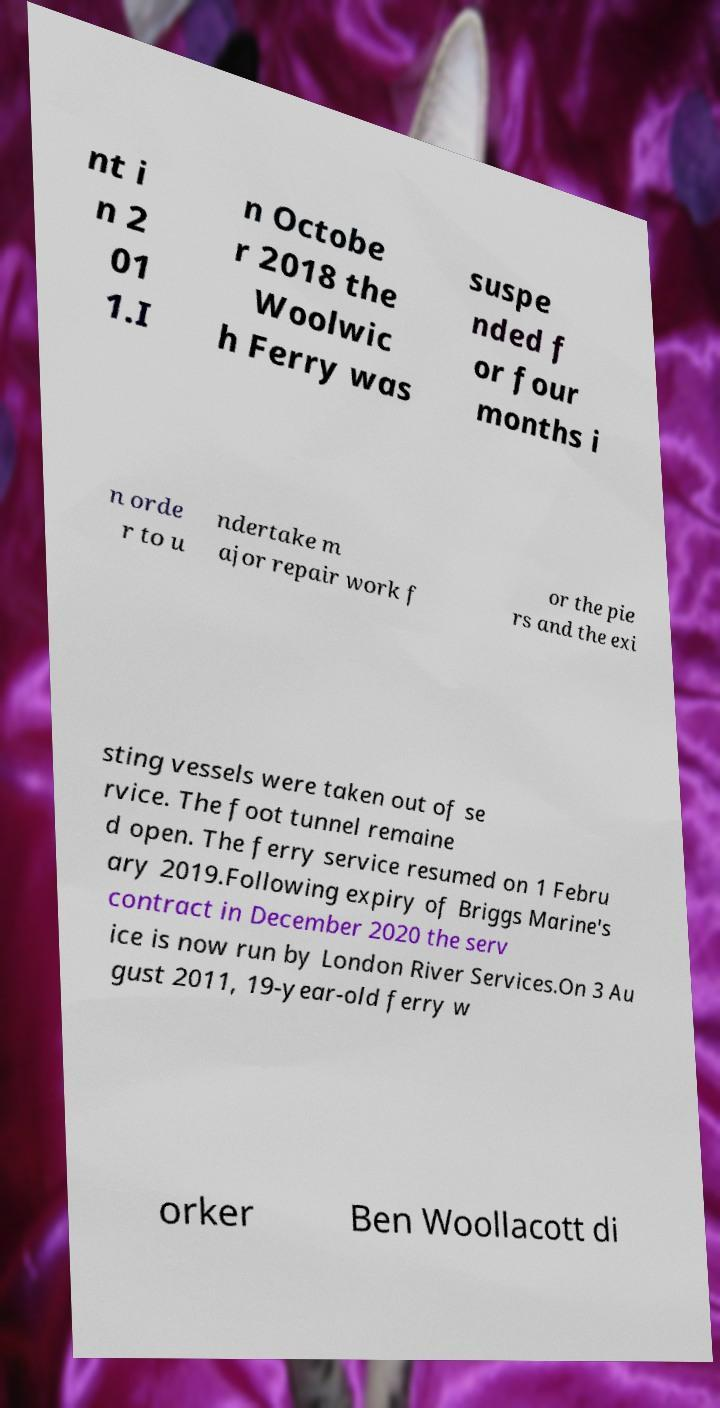Could you extract and type out the text from this image? nt i n 2 01 1.I n Octobe r 2018 the Woolwic h Ferry was suspe nded f or four months i n orde r to u ndertake m ajor repair work f or the pie rs and the exi sting vessels were taken out of se rvice. The foot tunnel remaine d open. The ferry service resumed on 1 Febru ary 2019.Following expiry of Briggs Marine's contract in December 2020 the serv ice is now run by London River Services.On 3 Au gust 2011, 19-year-old ferry w orker Ben Woollacott di 